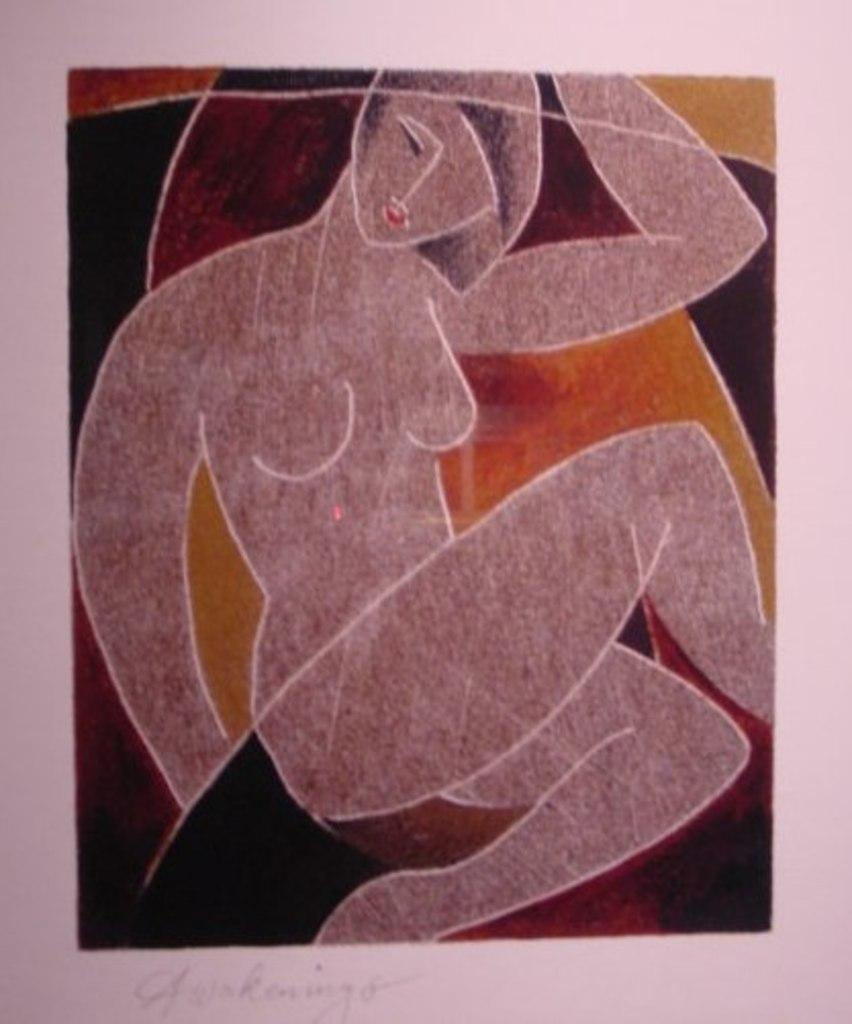What is the main subject of the image? There is a painting in the image. What is happening in the painting? The painting depicts a person sitting on an object. Is there any text associated with the painting? Yes, there is text at the bottom of the image. What type of loss is being experienced by the person in the painting? There is no indication of any loss in the painting; it simply depicts a person sitting on an object. Where is the lunchroom located in the image? There is no lunchroom present in the image; it features a painting with a person sitting on an object and text at the bottom. 